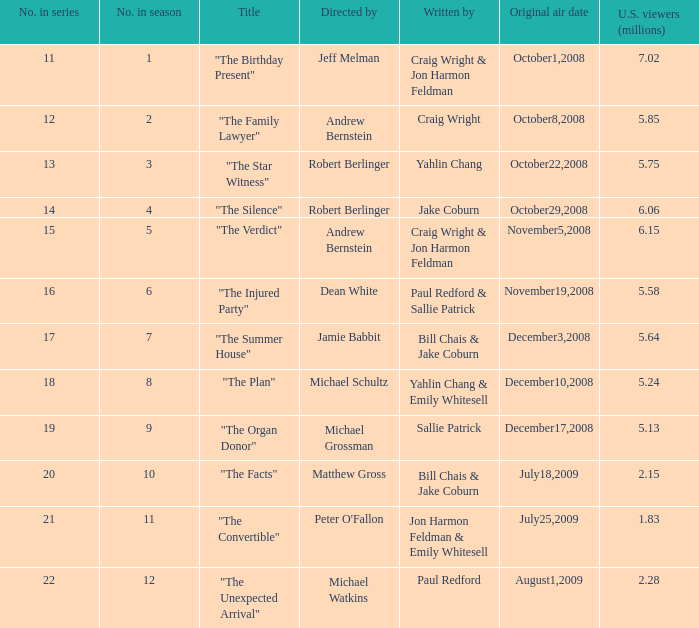Which writer was responsible for the episode that attracted 1.83 million viewers in the u.s.? Jon Harmon Feldman & Emily Whitesell. 